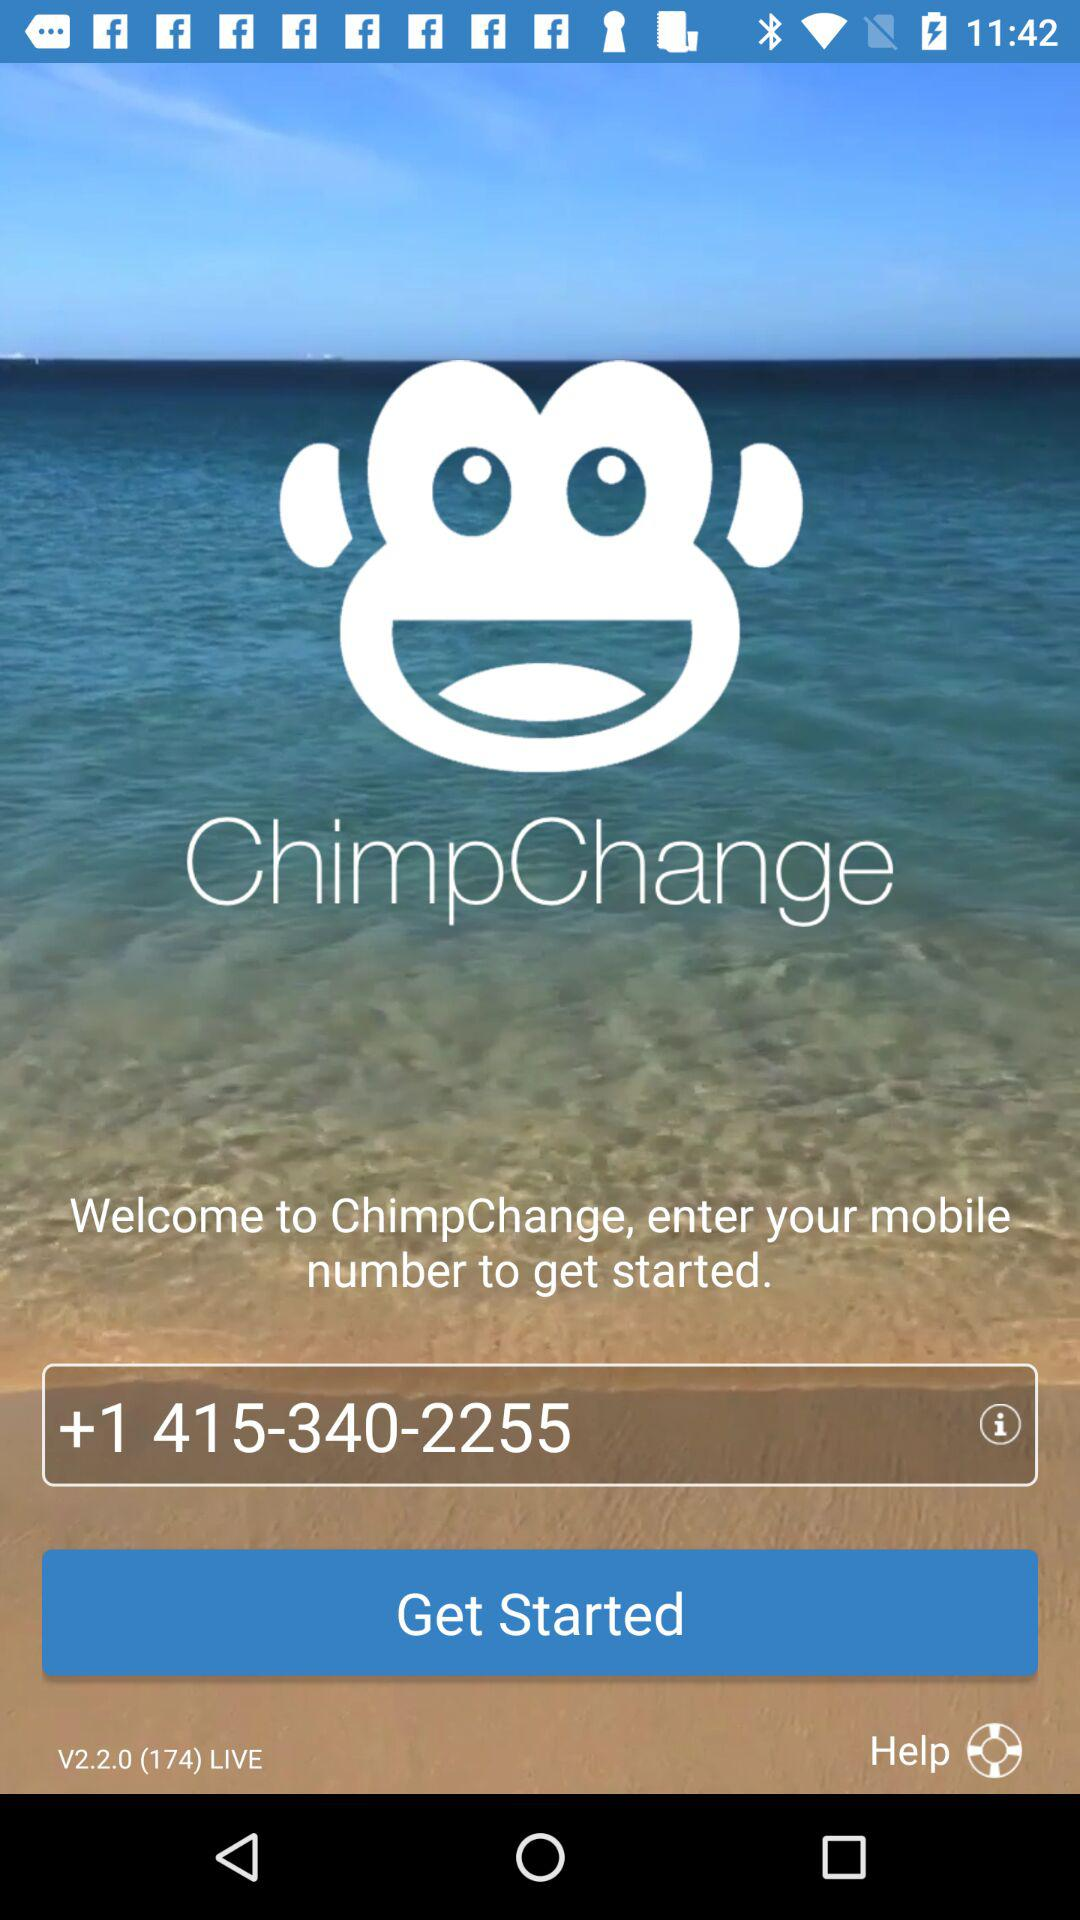What is the version of the application being used? The version of the application is "V2.2.0 (174) LIVE". 